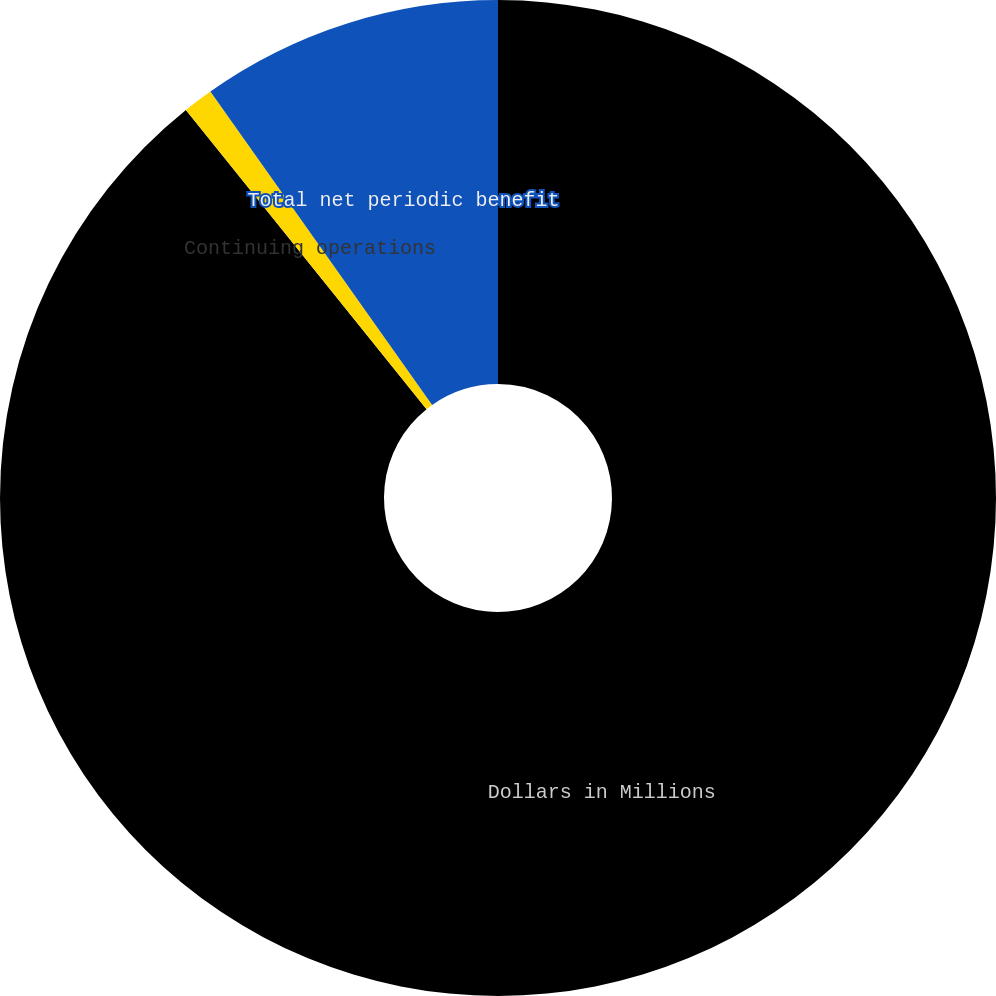Convert chart. <chart><loc_0><loc_0><loc_500><loc_500><pie_chart><fcel>Dollars in Millions<fcel>Continuing operations<fcel>Total net periodic benefit<nl><fcel>89.22%<fcel>0.98%<fcel>9.8%<nl></chart> 